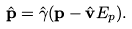<formula> <loc_0><loc_0><loc_500><loc_500>\hat { \mathbf p } = \hat { \gamma } ( { \mathbf p } - \hat { \mathbf v } E _ { p } ) .</formula> 